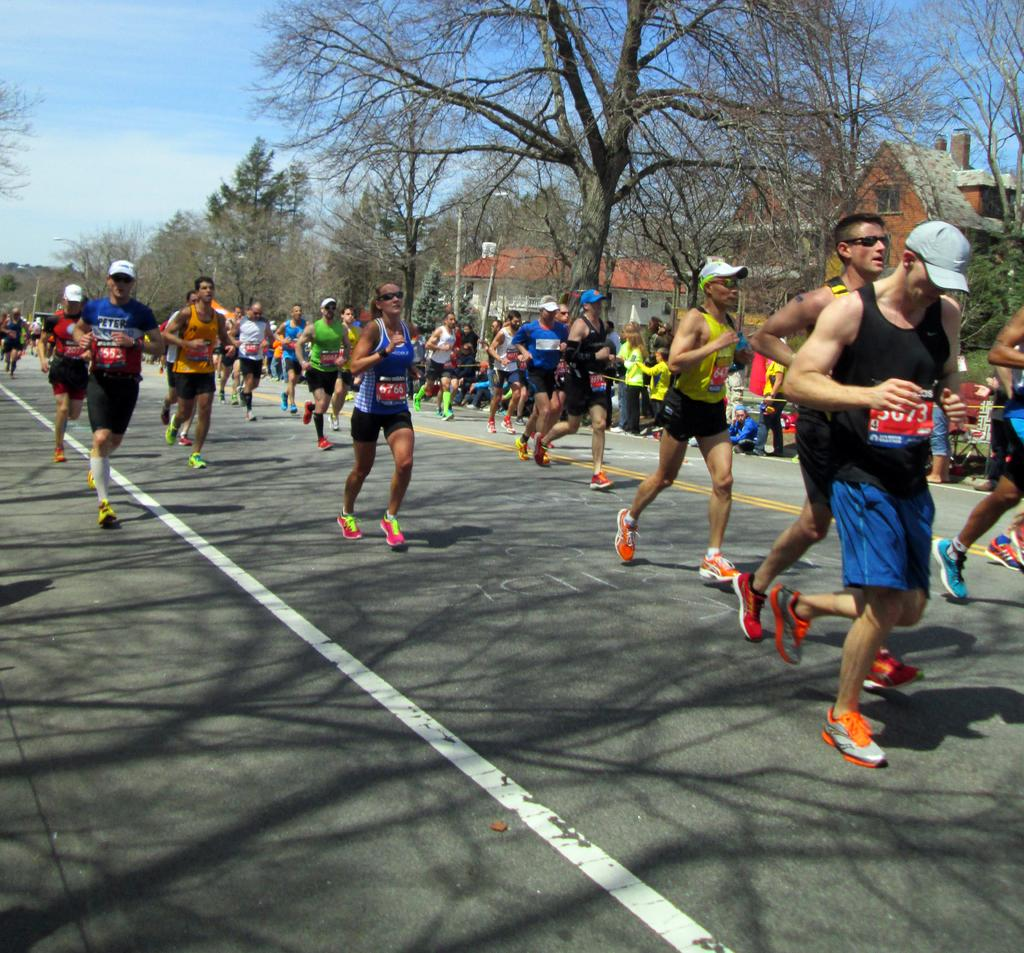What are the people in the image doing? The people in the image are running on the road. What can be seen in the background of the image? There are trees, buildings, and the sky visible in the background of the image. What type of plate is being used by the people running in the image? There is no plate present in the image, as the people are running on the road. What drug is being administered to the trees in the background of the image? There is no drug being administered to the trees in the image; they are simply visible in the background. 